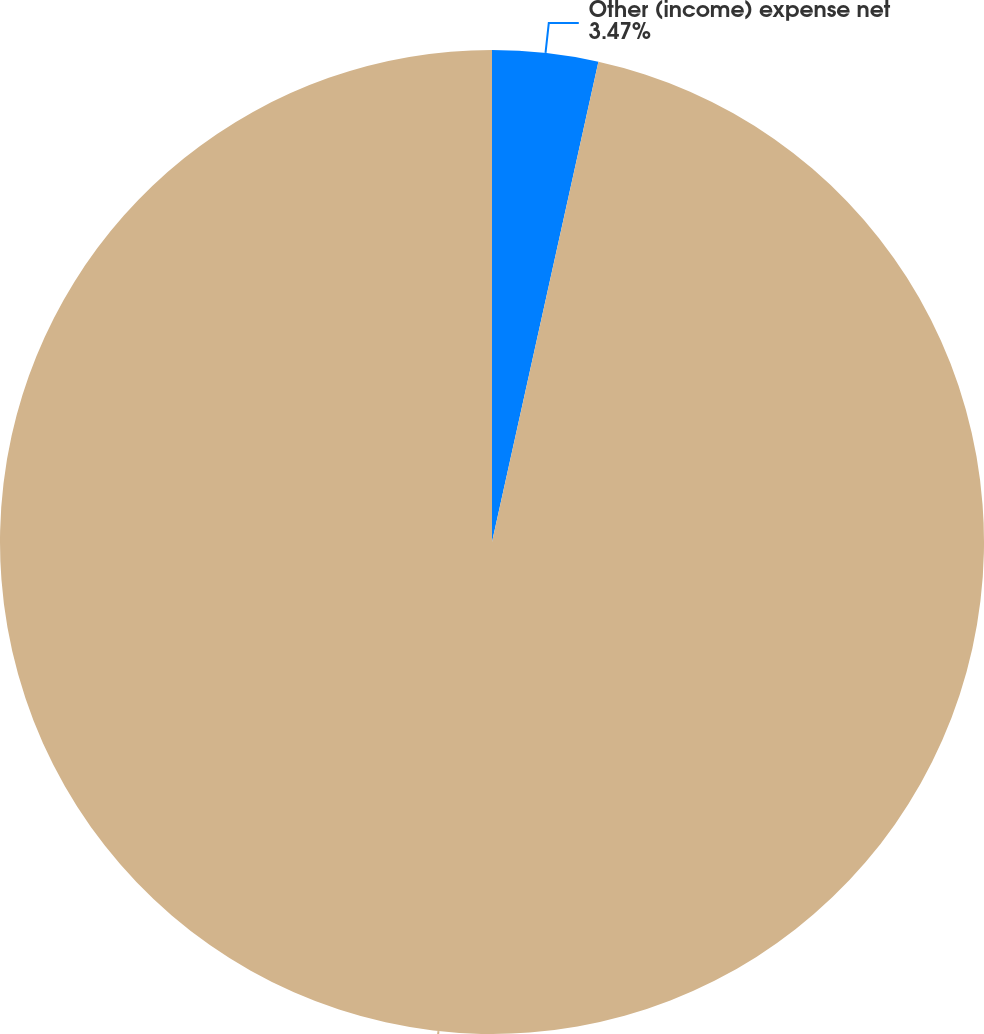<chart> <loc_0><loc_0><loc_500><loc_500><pie_chart><fcel>Other (income) expense net<fcel>2012 Restructuring Program<nl><fcel>3.47%<fcel>96.53%<nl></chart> 